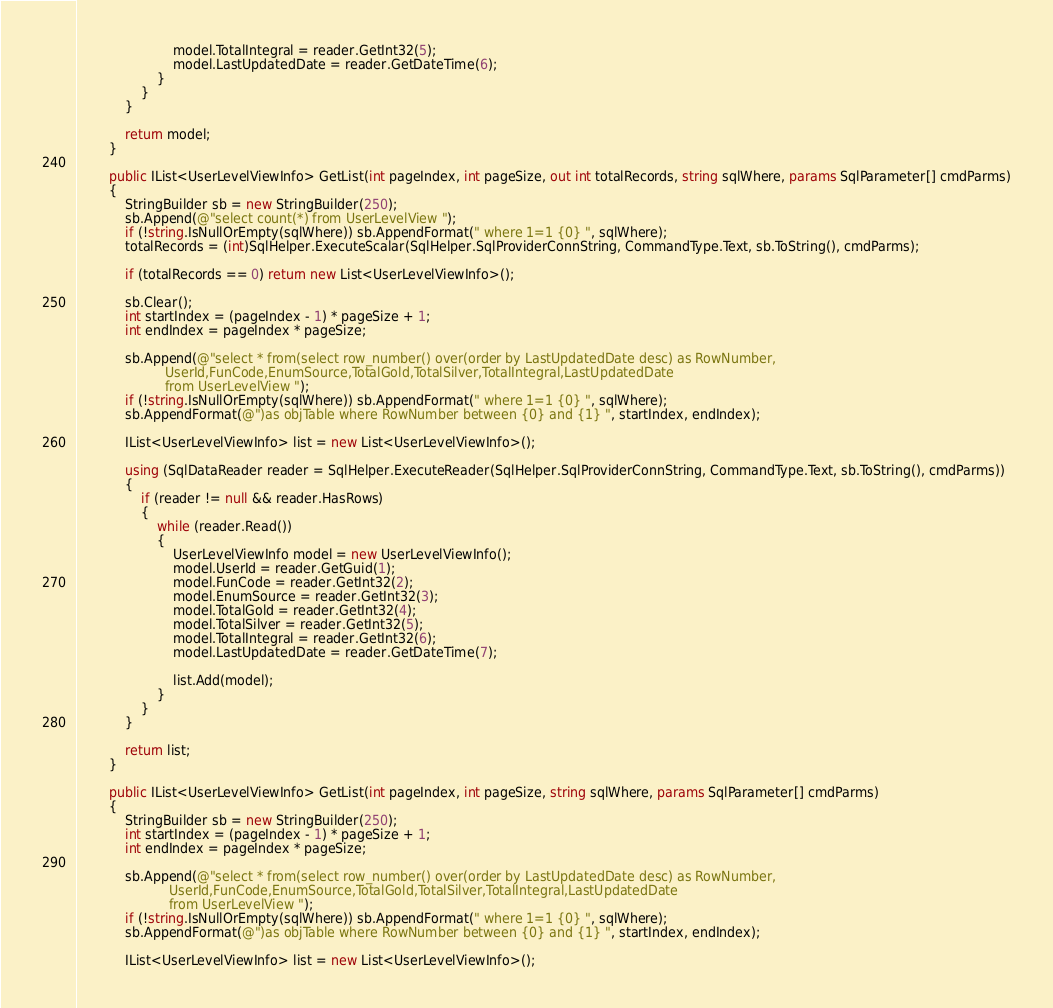Convert code to text. <code><loc_0><loc_0><loc_500><loc_500><_C#_>                        model.TotalIntegral = reader.GetInt32(5);
                        model.LastUpdatedDate = reader.GetDateTime(6);
                    }
                }
            }

            return model;
        }

        public IList<UserLevelViewInfo> GetList(int pageIndex, int pageSize, out int totalRecords, string sqlWhere, params SqlParameter[] cmdParms)
        {
            StringBuilder sb = new StringBuilder(250);
            sb.Append(@"select count(*) from UserLevelView ");
            if (!string.IsNullOrEmpty(sqlWhere)) sb.AppendFormat(" where 1=1 {0} ", sqlWhere);
            totalRecords = (int)SqlHelper.ExecuteScalar(SqlHelper.SqlProviderConnString, CommandType.Text, sb.ToString(), cmdParms);

            if (totalRecords == 0) return new List<UserLevelViewInfo>();

            sb.Clear();
            int startIndex = (pageIndex - 1) * pageSize + 1;
            int endIndex = pageIndex * pageSize;

            sb.Append(@"select * from(select row_number() over(order by LastUpdatedDate desc) as RowNumber,
			          UserId,FunCode,EnumSource,TotalGold,TotalSilver,TotalIntegral,LastUpdatedDate
					  from UserLevelView ");
            if (!string.IsNullOrEmpty(sqlWhere)) sb.AppendFormat(" where 1=1 {0} ", sqlWhere);
            sb.AppendFormat(@")as objTable where RowNumber between {0} and {1} ", startIndex, endIndex);

            IList<UserLevelViewInfo> list = new List<UserLevelViewInfo>();

            using (SqlDataReader reader = SqlHelper.ExecuteReader(SqlHelper.SqlProviderConnString, CommandType.Text, sb.ToString(), cmdParms))
            {
                if (reader != null && reader.HasRows)
                {
                    while (reader.Read())
                    {
                        UserLevelViewInfo model = new UserLevelViewInfo();
                        model.UserId = reader.GetGuid(1);
                        model.FunCode = reader.GetInt32(2);
                        model.EnumSource = reader.GetInt32(3);
                        model.TotalGold = reader.GetInt32(4);
                        model.TotalSilver = reader.GetInt32(5);
                        model.TotalIntegral = reader.GetInt32(6);
                        model.LastUpdatedDate = reader.GetDateTime(7);

                        list.Add(model);
                    }
                }
            }

            return list;
        }

        public IList<UserLevelViewInfo> GetList(int pageIndex, int pageSize, string sqlWhere, params SqlParameter[] cmdParms)
        {
            StringBuilder sb = new StringBuilder(250);
            int startIndex = (pageIndex - 1) * pageSize + 1;
            int endIndex = pageIndex * pageSize;

            sb.Append(@"select * from(select row_number() over(order by LastUpdatedDate desc) as RowNumber,
			           UserId,FunCode,EnumSource,TotalGold,TotalSilver,TotalIntegral,LastUpdatedDate
					   from UserLevelView ");
            if (!string.IsNullOrEmpty(sqlWhere)) sb.AppendFormat(" where 1=1 {0} ", sqlWhere);
            sb.AppendFormat(@")as objTable where RowNumber between {0} and {1} ", startIndex, endIndex);

            IList<UserLevelViewInfo> list = new List<UserLevelViewInfo>();
</code> 